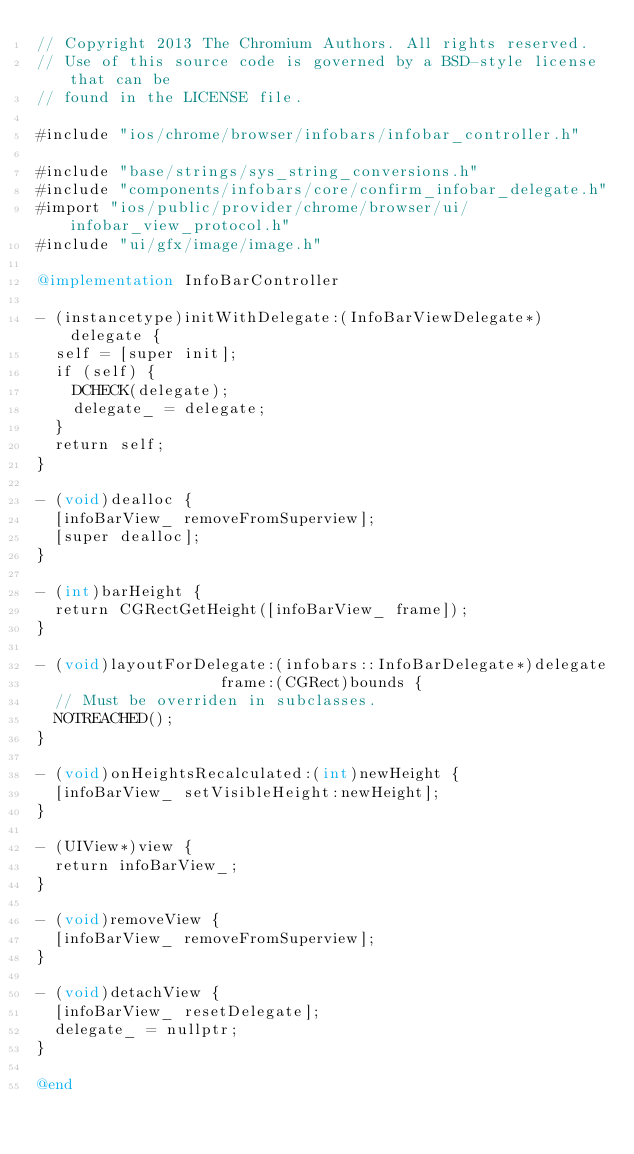Convert code to text. <code><loc_0><loc_0><loc_500><loc_500><_ObjectiveC_>// Copyright 2013 The Chromium Authors. All rights reserved.
// Use of this source code is governed by a BSD-style license that can be
// found in the LICENSE file.

#include "ios/chrome/browser/infobars/infobar_controller.h"

#include "base/strings/sys_string_conversions.h"
#include "components/infobars/core/confirm_infobar_delegate.h"
#import "ios/public/provider/chrome/browser/ui/infobar_view_protocol.h"
#include "ui/gfx/image/image.h"

@implementation InfoBarController

- (instancetype)initWithDelegate:(InfoBarViewDelegate*)delegate {
  self = [super init];
  if (self) {
    DCHECK(delegate);
    delegate_ = delegate;
  }
  return self;
}

- (void)dealloc {
  [infoBarView_ removeFromSuperview];
  [super dealloc];
}

- (int)barHeight {
  return CGRectGetHeight([infoBarView_ frame]);
}

- (void)layoutForDelegate:(infobars::InfoBarDelegate*)delegate
                    frame:(CGRect)bounds {
  // Must be overriden in subclasses.
  NOTREACHED();
}

- (void)onHeightsRecalculated:(int)newHeight {
  [infoBarView_ setVisibleHeight:newHeight];
}

- (UIView*)view {
  return infoBarView_;
}

- (void)removeView {
  [infoBarView_ removeFromSuperview];
}

- (void)detachView {
  [infoBarView_ resetDelegate];
  delegate_ = nullptr;
}

@end
</code> 